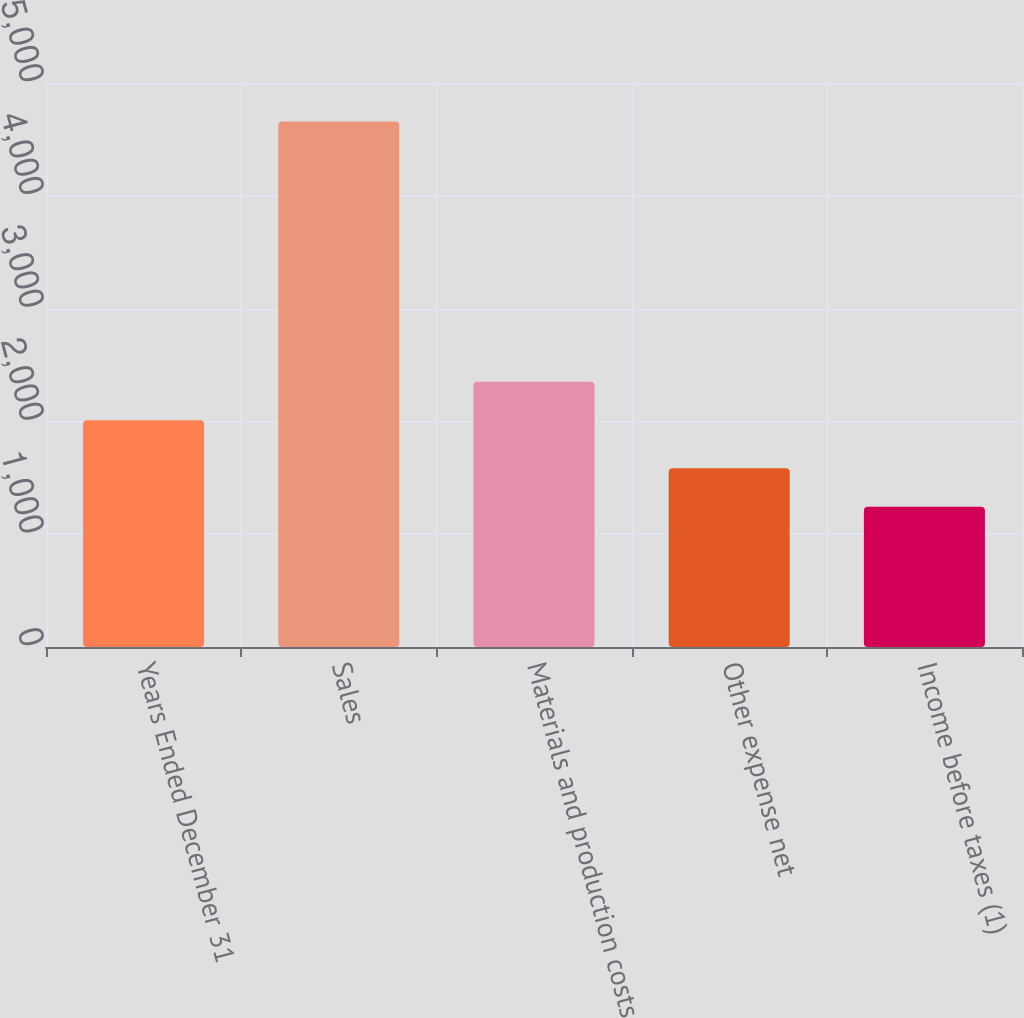Convert chart to OTSL. <chart><loc_0><loc_0><loc_500><loc_500><bar_chart><fcel>Years Ended December 31<fcel>Sales<fcel>Materials and production costs<fcel>Other expense net<fcel>Income before taxes (1)<nl><fcel>2011<fcel>4659<fcel>2352.5<fcel>1585.5<fcel>1244<nl></chart> 